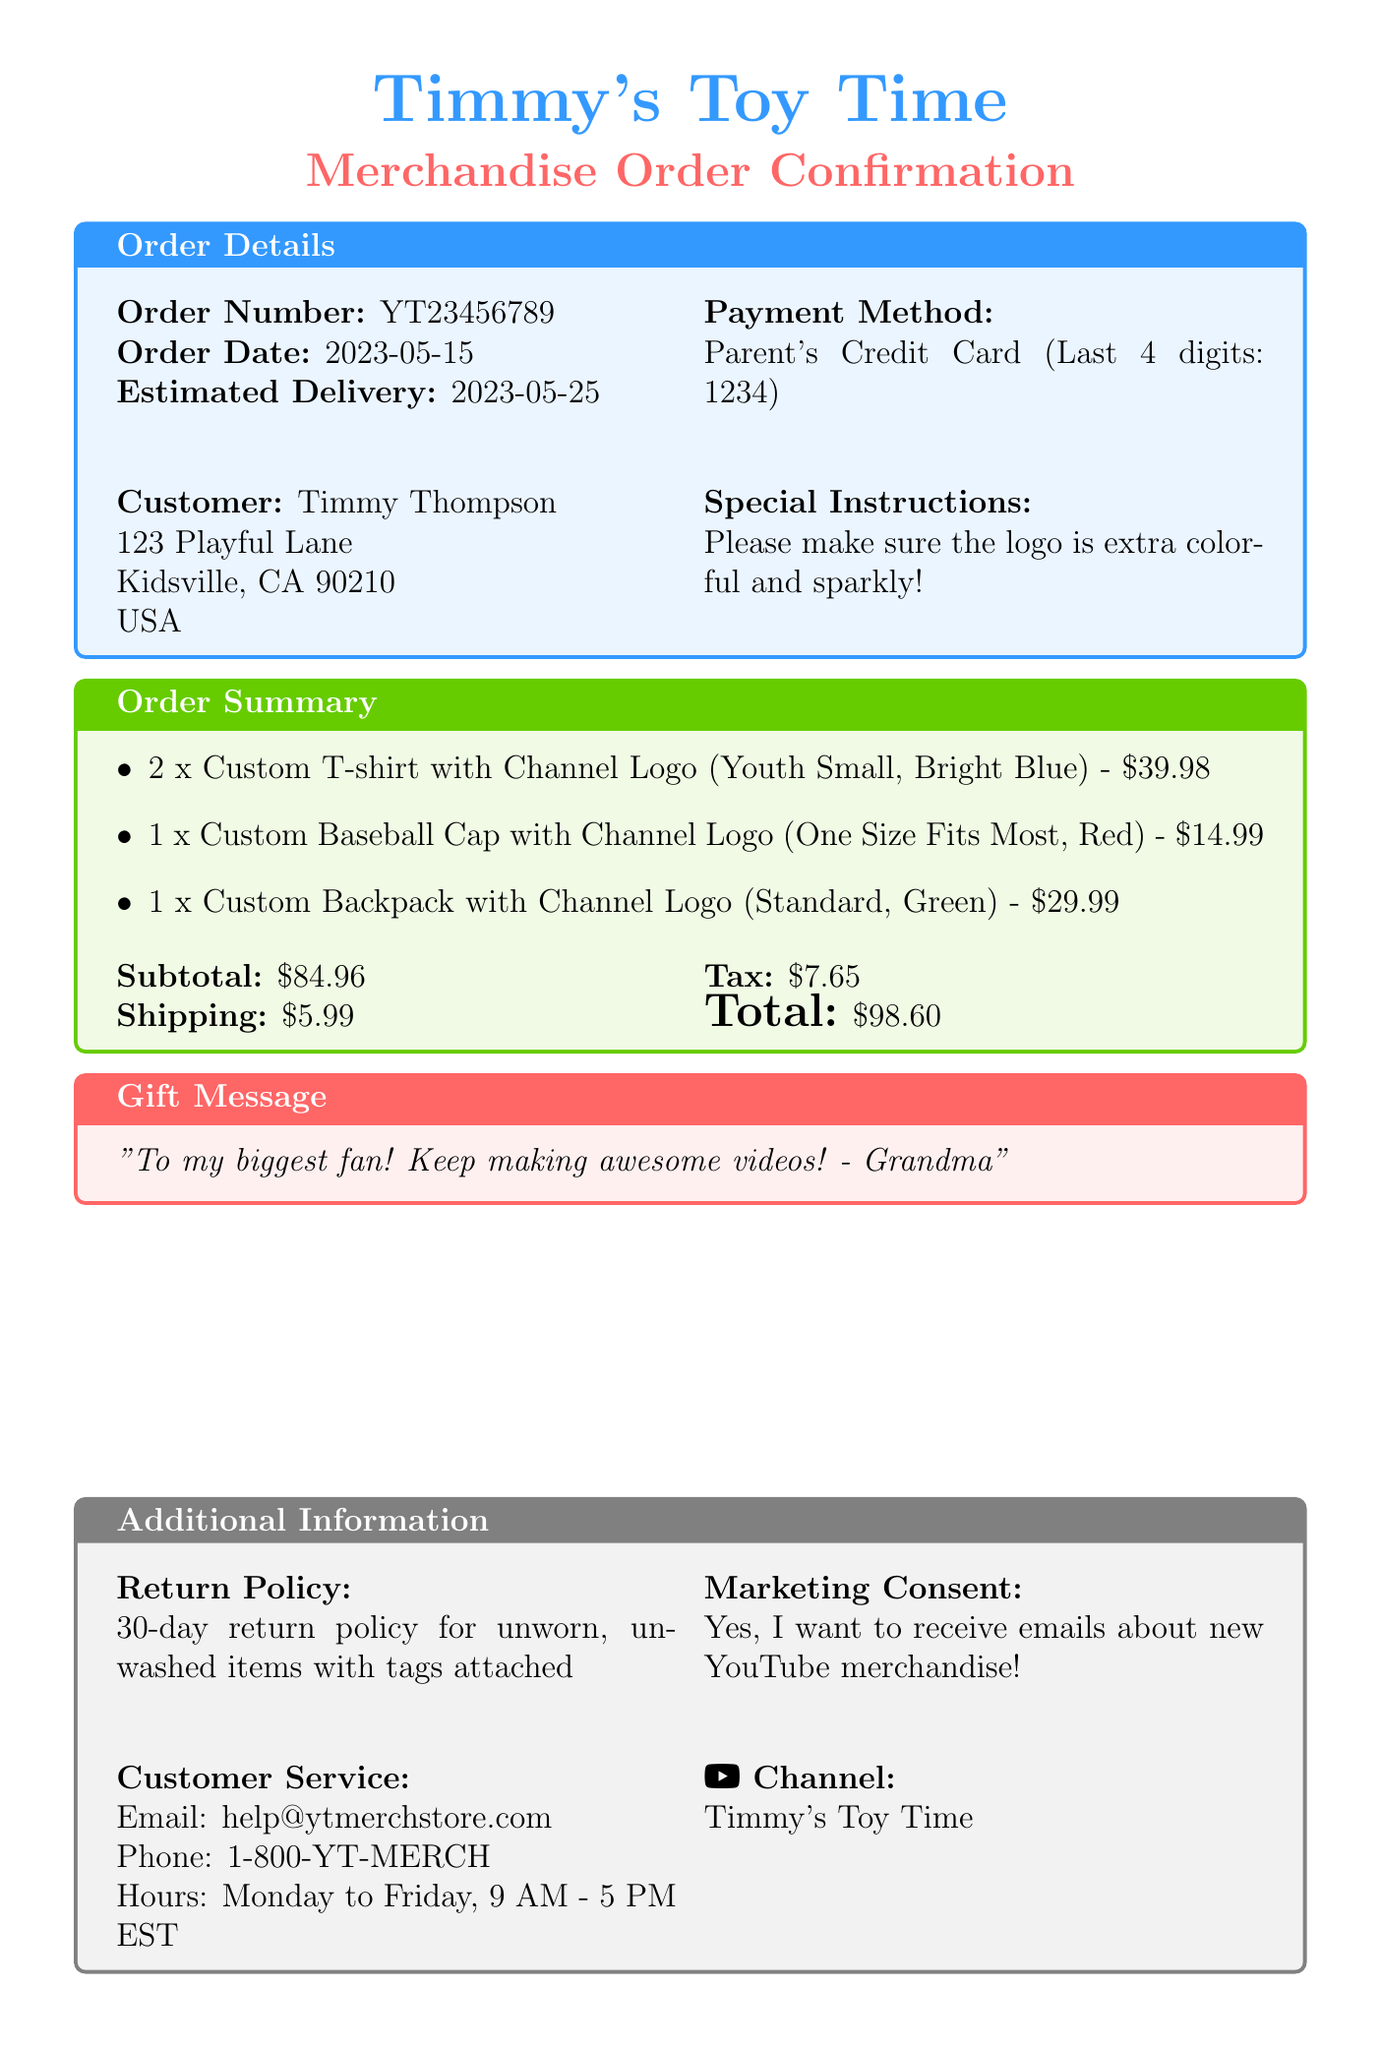What is the order number? The order number is specified in the document under order details.
Answer: YT23456789 What is the estimated delivery date? The estimated delivery date is provided in the order details section.
Answer: 2023-05-25 Who is the customer? The customer's name is found in the order details of the document.
Answer: Timmy Thompson How many custom T-shirts were ordered? The quantity of custom T-shirts is mentioned in the items section.
Answer: 2 What color is the custom baseball cap? The color of the baseball cap is listed in the items section.
Answer: Red What is the subtotal amount? The subtotal amount is provided in the order summary section.
Answer: $84.96 What special instructions were given? The special instructions are stated in the order details section.
Answer: Please make sure the logo is extra colorful and sparkly! What is the return policy duration? The return policy duration is specified in the additional information section.
Answer: 30-day What gift message is included? The gift message is found in the gift message section of the document.
Answer: To my biggest fan! Keep making awesome videos! - Grandma 